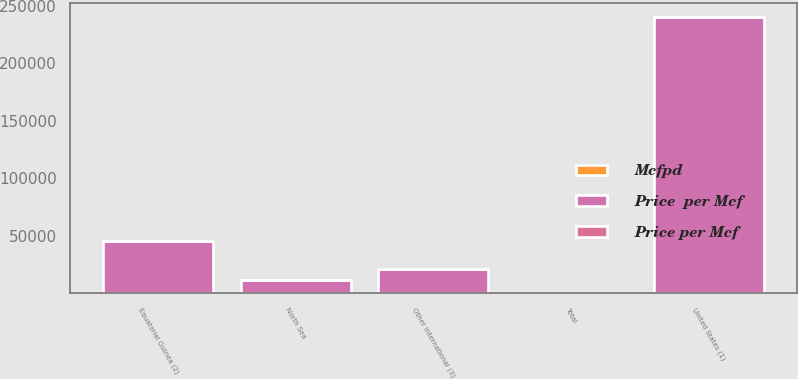Convert chart to OTSL. <chart><loc_0><loc_0><loc_500><loc_500><stacked_bar_chart><ecel><fcel>United States (1)<fcel>Equatorial Guinea (2)<fcel>North Sea<fcel>Other International (3)<fcel>Total<nl><fcel>Price  per Mcf<fcel>240647<fcel>45755<fcel>11286<fcel>21262<fcel>3.985<nl><fcel>Price per Mcf<fcel>6<fcel>0.25<fcel>4.73<fcel>0.75<fcel>4.74<nl><fcel>Mcfpd<fcel>3.24<fcel>0.25<fcel>3.14<fcel>0.38<fcel>2.89<nl></chart> 